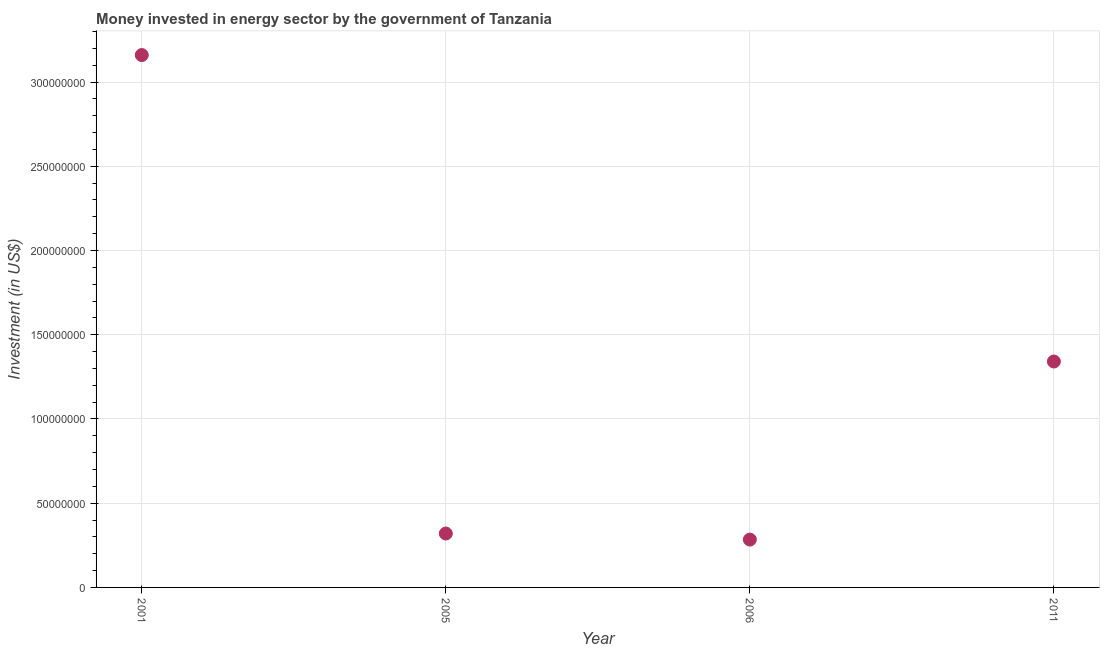What is the investment in energy in 2011?
Make the answer very short. 1.34e+08. Across all years, what is the maximum investment in energy?
Your response must be concise. 3.16e+08. Across all years, what is the minimum investment in energy?
Ensure brevity in your answer.  2.84e+07. What is the sum of the investment in energy?
Your response must be concise. 5.10e+08. What is the difference between the investment in energy in 2005 and 2011?
Your response must be concise. -1.02e+08. What is the average investment in energy per year?
Keep it short and to the point. 1.28e+08. What is the median investment in energy?
Your answer should be very brief. 8.30e+07. In how many years, is the investment in energy greater than 20000000 US$?
Keep it short and to the point. 4. What is the ratio of the investment in energy in 2006 to that in 2011?
Provide a succinct answer. 0.21. Is the difference between the investment in energy in 2001 and 2011 greater than the difference between any two years?
Your answer should be compact. No. What is the difference between the highest and the second highest investment in energy?
Provide a succinct answer. 1.82e+08. What is the difference between the highest and the lowest investment in energy?
Provide a short and direct response. 2.88e+08. How many dotlines are there?
Keep it short and to the point. 1. Does the graph contain any zero values?
Provide a succinct answer. No. What is the title of the graph?
Your answer should be compact. Money invested in energy sector by the government of Tanzania. What is the label or title of the X-axis?
Provide a short and direct response. Year. What is the label or title of the Y-axis?
Your answer should be very brief. Investment (in US$). What is the Investment (in US$) in 2001?
Provide a short and direct response. 3.16e+08. What is the Investment (in US$) in 2005?
Your answer should be compact. 3.20e+07. What is the Investment (in US$) in 2006?
Give a very brief answer. 2.84e+07. What is the Investment (in US$) in 2011?
Your response must be concise. 1.34e+08. What is the difference between the Investment (in US$) in 2001 and 2005?
Provide a succinct answer. 2.84e+08. What is the difference between the Investment (in US$) in 2001 and 2006?
Your answer should be very brief. 2.88e+08. What is the difference between the Investment (in US$) in 2001 and 2011?
Offer a terse response. 1.82e+08. What is the difference between the Investment (in US$) in 2005 and 2006?
Provide a succinct answer. 3.60e+06. What is the difference between the Investment (in US$) in 2005 and 2011?
Your response must be concise. -1.02e+08. What is the difference between the Investment (in US$) in 2006 and 2011?
Your answer should be compact. -1.06e+08. What is the ratio of the Investment (in US$) in 2001 to that in 2005?
Your answer should be compact. 9.88. What is the ratio of the Investment (in US$) in 2001 to that in 2006?
Make the answer very short. 11.13. What is the ratio of the Investment (in US$) in 2001 to that in 2011?
Offer a terse response. 2.36. What is the ratio of the Investment (in US$) in 2005 to that in 2006?
Provide a succinct answer. 1.13. What is the ratio of the Investment (in US$) in 2005 to that in 2011?
Give a very brief answer. 0.24. What is the ratio of the Investment (in US$) in 2006 to that in 2011?
Your response must be concise. 0.21. 